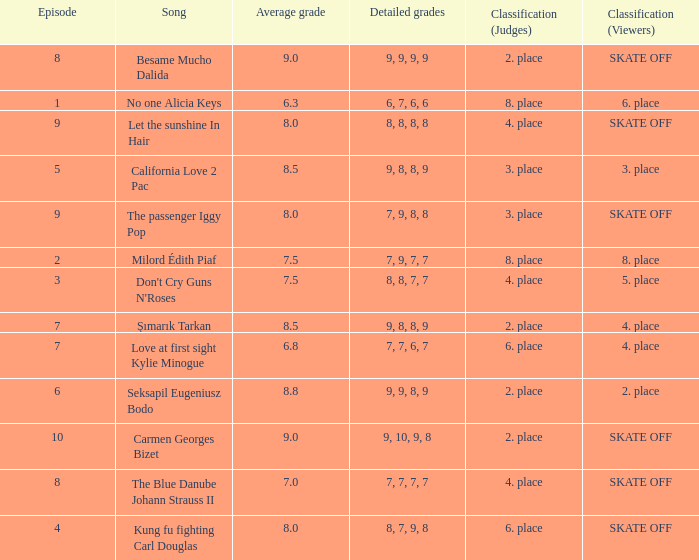Determine the class for 9, 9, 8, 9 2. place. 